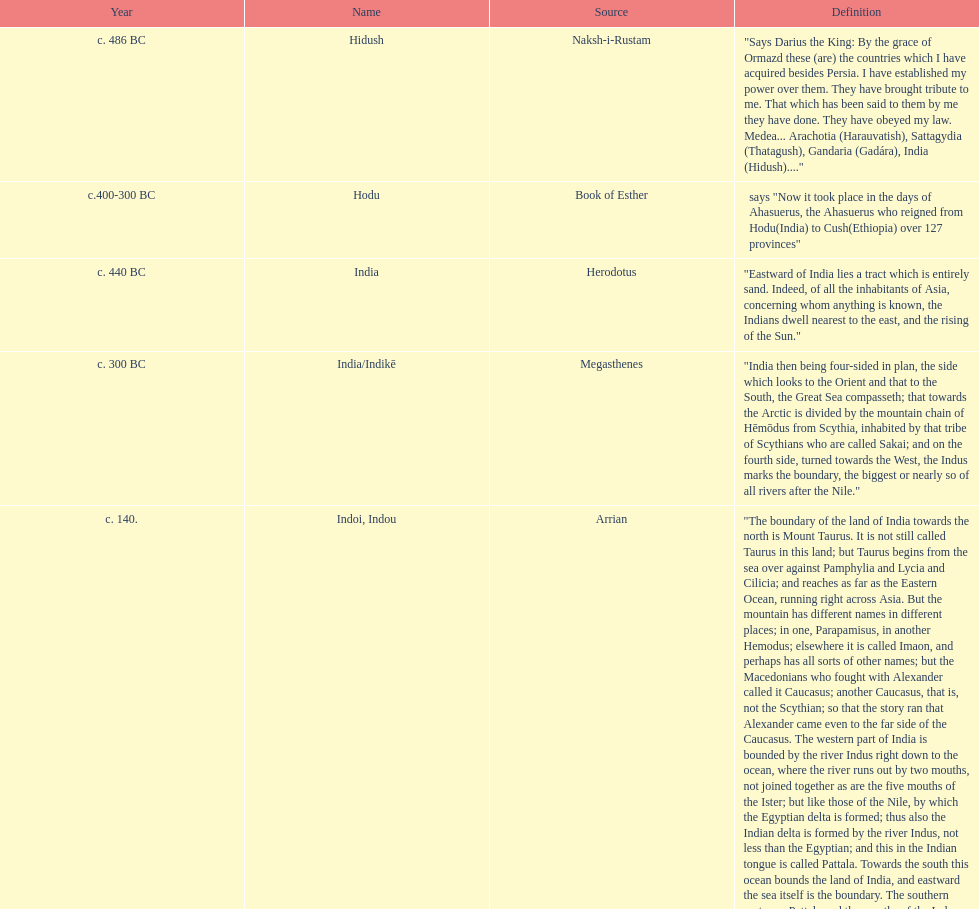Which is the newest source for the name? Clavijo. 